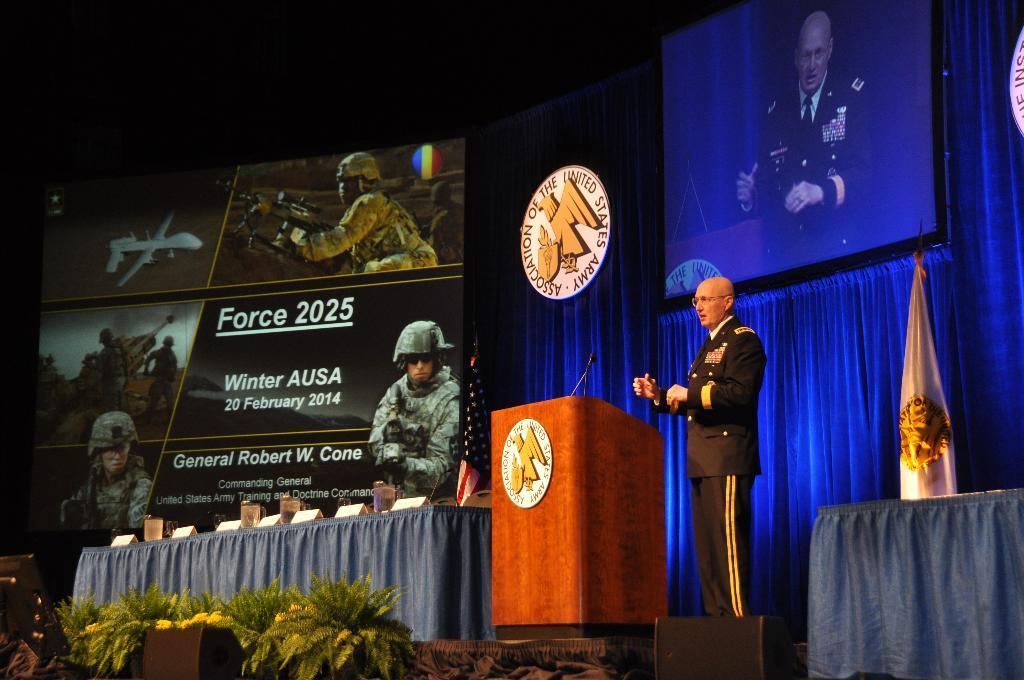Can you describe this image briefly? In this picture there is a person standing and talking. There is a microphone on the podium and there are glasses and boards on the table. At the back there is a flag, curtain and there is a screen, in the screen there is a person standing and talking. There is a hoarding. At the bottom there are plants and speakers on the stage. 